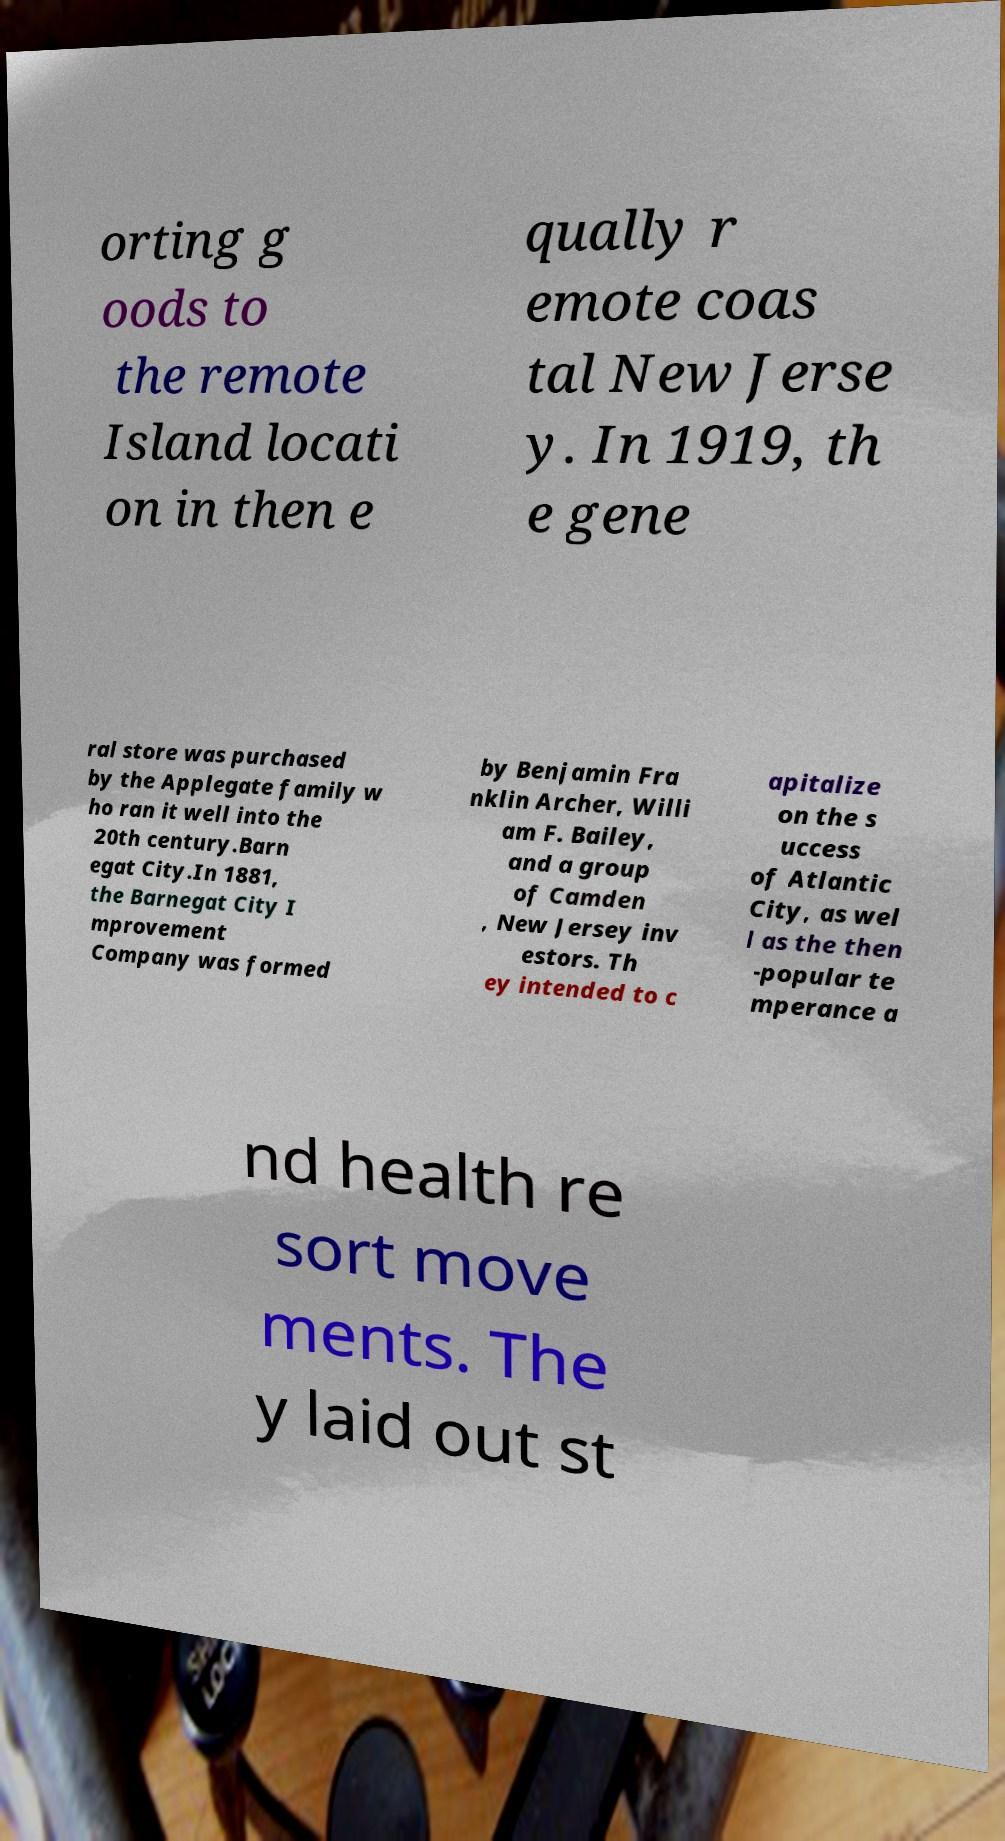There's text embedded in this image that I need extracted. Can you transcribe it verbatim? orting g oods to the remote Island locati on in then e qually r emote coas tal New Jerse y. In 1919, th e gene ral store was purchased by the Applegate family w ho ran it well into the 20th century.Barn egat City.In 1881, the Barnegat City I mprovement Company was formed by Benjamin Fra nklin Archer, Willi am F. Bailey, and a group of Camden , New Jersey inv estors. Th ey intended to c apitalize on the s uccess of Atlantic City, as wel l as the then -popular te mperance a nd health re sort move ments. The y laid out st 